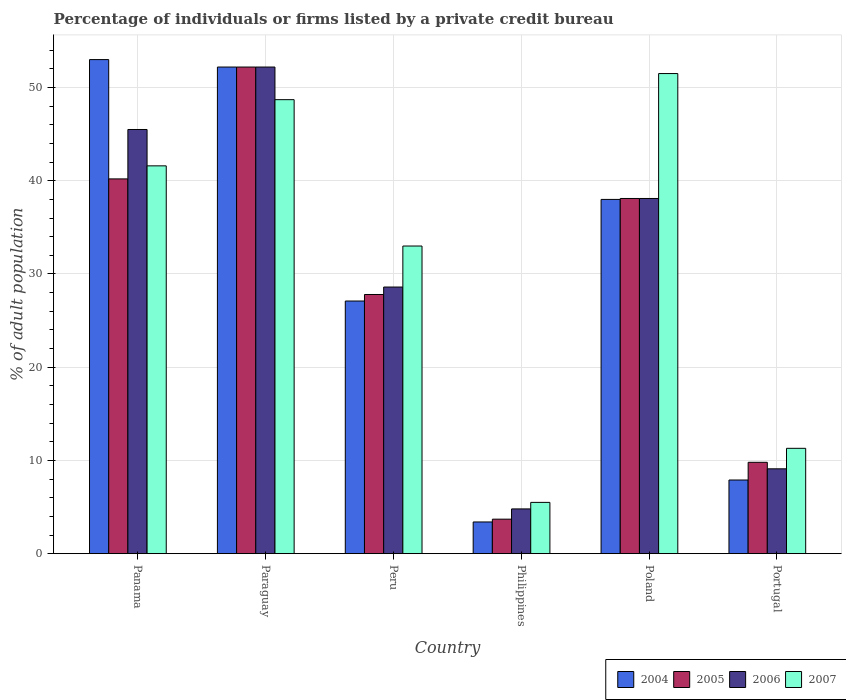How many different coloured bars are there?
Give a very brief answer. 4. Are the number of bars per tick equal to the number of legend labels?
Offer a terse response. Yes. Are the number of bars on each tick of the X-axis equal?
Your answer should be compact. Yes. What is the label of the 3rd group of bars from the left?
Your answer should be very brief. Peru. In how many cases, is the number of bars for a given country not equal to the number of legend labels?
Provide a succinct answer. 0. What is the percentage of population listed by a private credit bureau in 2007 in Paraguay?
Your answer should be very brief. 48.7. Across all countries, what is the maximum percentage of population listed by a private credit bureau in 2004?
Your response must be concise. 53. Across all countries, what is the minimum percentage of population listed by a private credit bureau in 2007?
Provide a succinct answer. 5.5. In which country was the percentage of population listed by a private credit bureau in 2005 maximum?
Give a very brief answer. Paraguay. What is the total percentage of population listed by a private credit bureau in 2004 in the graph?
Provide a short and direct response. 181.6. What is the difference between the percentage of population listed by a private credit bureau in 2004 in Panama and that in Philippines?
Keep it short and to the point. 49.6. What is the difference between the percentage of population listed by a private credit bureau in 2004 in Paraguay and the percentage of population listed by a private credit bureau in 2007 in Peru?
Make the answer very short. 19.2. What is the average percentage of population listed by a private credit bureau in 2004 per country?
Provide a short and direct response. 30.27. What is the difference between the percentage of population listed by a private credit bureau of/in 2006 and percentage of population listed by a private credit bureau of/in 2007 in Peru?
Ensure brevity in your answer.  -4.4. In how many countries, is the percentage of population listed by a private credit bureau in 2007 greater than 40 %?
Your answer should be very brief. 3. What is the ratio of the percentage of population listed by a private credit bureau in 2007 in Philippines to that in Portugal?
Ensure brevity in your answer.  0.49. Is the difference between the percentage of population listed by a private credit bureau in 2006 in Paraguay and Philippines greater than the difference between the percentage of population listed by a private credit bureau in 2007 in Paraguay and Philippines?
Ensure brevity in your answer.  Yes. What is the difference between the highest and the second highest percentage of population listed by a private credit bureau in 2006?
Give a very brief answer. 6.7. What is the difference between the highest and the lowest percentage of population listed by a private credit bureau in 2005?
Offer a terse response. 48.5. What does the 2nd bar from the left in Paraguay represents?
Provide a short and direct response. 2005. Is it the case that in every country, the sum of the percentage of population listed by a private credit bureau in 2005 and percentage of population listed by a private credit bureau in 2007 is greater than the percentage of population listed by a private credit bureau in 2006?
Your response must be concise. Yes. How many bars are there?
Keep it short and to the point. 24. Are all the bars in the graph horizontal?
Provide a succinct answer. No. Are the values on the major ticks of Y-axis written in scientific E-notation?
Your response must be concise. No. Does the graph contain any zero values?
Provide a succinct answer. No. Where does the legend appear in the graph?
Your response must be concise. Bottom right. How many legend labels are there?
Ensure brevity in your answer.  4. What is the title of the graph?
Your response must be concise. Percentage of individuals or firms listed by a private credit bureau. Does "1986" appear as one of the legend labels in the graph?
Make the answer very short. No. What is the label or title of the Y-axis?
Ensure brevity in your answer.  % of adult population. What is the % of adult population of 2005 in Panama?
Make the answer very short. 40.2. What is the % of adult population in 2006 in Panama?
Provide a succinct answer. 45.5. What is the % of adult population in 2007 in Panama?
Ensure brevity in your answer.  41.6. What is the % of adult population in 2004 in Paraguay?
Provide a short and direct response. 52.2. What is the % of adult population in 2005 in Paraguay?
Your answer should be very brief. 52.2. What is the % of adult population in 2006 in Paraguay?
Offer a very short reply. 52.2. What is the % of adult population in 2007 in Paraguay?
Provide a short and direct response. 48.7. What is the % of adult population of 2004 in Peru?
Offer a terse response. 27.1. What is the % of adult population in 2005 in Peru?
Give a very brief answer. 27.8. What is the % of adult population in 2006 in Peru?
Your answer should be very brief. 28.6. What is the % of adult population in 2004 in Philippines?
Offer a terse response. 3.4. What is the % of adult population in 2005 in Philippines?
Ensure brevity in your answer.  3.7. What is the % of adult population of 2006 in Philippines?
Provide a short and direct response. 4.8. What is the % of adult population in 2005 in Poland?
Give a very brief answer. 38.1. What is the % of adult population of 2006 in Poland?
Your response must be concise. 38.1. What is the % of adult population of 2007 in Poland?
Ensure brevity in your answer.  51.5. What is the % of adult population of 2004 in Portugal?
Make the answer very short. 7.9. What is the % of adult population of 2005 in Portugal?
Make the answer very short. 9.8. What is the % of adult population in 2007 in Portugal?
Your answer should be very brief. 11.3. Across all countries, what is the maximum % of adult population in 2005?
Provide a succinct answer. 52.2. Across all countries, what is the maximum % of adult population of 2006?
Provide a short and direct response. 52.2. Across all countries, what is the maximum % of adult population in 2007?
Your answer should be compact. 51.5. Across all countries, what is the minimum % of adult population in 2005?
Offer a very short reply. 3.7. Across all countries, what is the minimum % of adult population in 2006?
Provide a short and direct response. 4.8. What is the total % of adult population of 2004 in the graph?
Your answer should be very brief. 181.6. What is the total % of adult population in 2005 in the graph?
Offer a terse response. 171.8. What is the total % of adult population of 2006 in the graph?
Your answer should be very brief. 178.3. What is the total % of adult population of 2007 in the graph?
Your answer should be compact. 191.6. What is the difference between the % of adult population in 2004 in Panama and that in Paraguay?
Offer a terse response. 0.8. What is the difference between the % of adult population in 2004 in Panama and that in Peru?
Your answer should be very brief. 25.9. What is the difference between the % of adult population in 2006 in Panama and that in Peru?
Provide a succinct answer. 16.9. What is the difference between the % of adult population in 2007 in Panama and that in Peru?
Your answer should be very brief. 8.6. What is the difference between the % of adult population of 2004 in Panama and that in Philippines?
Offer a very short reply. 49.6. What is the difference between the % of adult population in 2005 in Panama and that in Philippines?
Give a very brief answer. 36.5. What is the difference between the % of adult population in 2006 in Panama and that in Philippines?
Offer a terse response. 40.7. What is the difference between the % of adult population of 2007 in Panama and that in Philippines?
Make the answer very short. 36.1. What is the difference between the % of adult population of 2004 in Panama and that in Poland?
Provide a short and direct response. 15. What is the difference between the % of adult population in 2005 in Panama and that in Poland?
Your answer should be compact. 2.1. What is the difference between the % of adult population of 2006 in Panama and that in Poland?
Give a very brief answer. 7.4. What is the difference between the % of adult population of 2004 in Panama and that in Portugal?
Keep it short and to the point. 45.1. What is the difference between the % of adult population in 2005 in Panama and that in Portugal?
Keep it short and to the point. 30.4. What is the difference between the % of adult population in 2006 in Panama and that in Portugal?
Your response must be concise. 36.4. What is the difference between the % of adult population in 2007 in Panama and that in Portugal?
Ensure brevity in your answer.  30.3. What is the difference between the % of adult population of 2004 in Paraguay and that in Peru?
Make the answer very short. 25.1. What is the difference between the % of adult population of 2005 in Paraguay and that in Peru?
Offer a terse response. 24.4. What is the difference between the % of adult population in 2006 in Paraguay and that in Peru?
Offer a terse response. 23.6. What is the difference between the % of adult population of 2007 in Paraguay and that in Peru?
Provide a succinct answer. 15.7. What is the difference between the % of adult population of 2004 in Paraguay and that in Philippines?
Provide a short and direct response. 48.8. What is the difference between the % of adult population of 2005 in Paraguay and that in Philippines?
Your response must be concise. 48.5. What is the difference between the % of adult population of 2006 in Paraguay and that in Philippines?
Keep it short and to the point. 47.4. What is the difference between the % of adult population of 2007 in Paraguay and that in Philippines?
Offer a very short reply. 43.2. What is the difference between the % of adult population in 2004 in Paraguay and that in Poland?
Make the answer very short. 14.2. What is the difference between the % of adult population in 2005 in Paraguay and that in Poland?
Your response must be concise. 14.1. What is the difference between the % of adult population in 2007 in Paraguay and that in Poland?
Provide a short and direct response. -2.8. What is the difference between the % of adult population of 2004 in Paraguay and that in Portugal?
Your answer should be very brief. 44.3. What is the difference between the % of adult population in 2005 in Paraguay and that in Portugal?
Ensure brevity in your answer.  42.4. What is the difference between the % of adult population in 2006 in Paraguay and that in Portugal?
Offer a terse response. 43.1. What is the difference between the % of adult population in 2007 in Paraguay and that in Portugal?
Ensure brevity in your answer.  37.4. What is the difference between the % of adult population in 2004 in Peru and that in Philippines?
Ensure brevity in your answer.  23.7. What is the difference between the % of adult population of 2005 in Peru and that in Philippines?
Provide a succinct answer. 24.1. What is the difference between the % of adult population of 2006 in Peru and that in Philippines?
Make the answer very short. 23.8. What is the difference between the % of adult population of 2004 in Peru and that in Poland?
Keep it short and to the point. -10.9. What is the difference between the % of adult population in 2005 in Peru and that in Poland?
Your answer should be compact. -10.3. What is the difference between the % of adult population in 2007 in Peru and that in Poland?
Ensure brevity in your answer.  -18.5. What is the difference between the % of adult population of 2004 in Peru and that in Portugal?
Your answer should be very brief. 19.2. What is the difference between the % of adult population of 2007 in Peru and that in Portugal?
Your answer should be very brief. 21.7. What is the difference between the % of adult population in 2004 in Philippines and that in Poland?
Provide a short and direct response. -34.6. What is the difference between the % of adult population of 2005 in Philippines and that in Poland?
Your answer should be very brief. -34.4. What is the difference between the % of adult population of 2006 in Philippines and that in Poland?
Offer a terse response. -33.3. What is the difference between the % of adult population in 2007 in Philippines and that in Poland?
Ensure brevity in your answer.  -46. What is the difference between the % of adult population of 2004 in Philippines and that in Portugal?
Keep it short and to the point. -4.5. What is the difference between the % of adult population of 2006 in Philippines and that in Portugal?
Offer a very short reply. -4.3. What is the difference between the % of adult population in 2004 in Poland and that in Portugal?
Provide a short and direct response. 30.1. What is the difference between the % of adult population in 2005 in Poland and that in Portugal?
Give a very brief answer. 28.3. What is the difference between the % of adult population of 2007 in Poland and that in Portugal?
Offer a terse response. 40.2. What is the difference between the % of adult population of 2004 in Panama and the % of adult population of 2005 in Paraguay?
Ensure brevity in your answer.  0.8. What is the difference between the % of adult population in 2004 in Panama and the % of adult population in 2006 in Paraguay?
Offer a very short reply. 0.8. What is the difference between the % of adult population in 2005 in Panama and the % of adult population in 2007 in Paraguay?
Provide a succinct answer. -8.5. What is the difference between the % of adult population of 2006 in Panama and the % of adult population of 2007 in Paraguay?
Your answer should be very brief. -3.2. What is the difference between the % of adult population in 2004 in Panama and the % of adult population in 2005 in Peru?
Your response must be concise. 25.2. What is the difference between the % of adult population of 2004 in Panama and the % of adult population of 2006 in Peru?
Give a very brief answer. 24.4. What is the difference between the % of adult population in 2004 in Panama and the % of adult population in 2007 in Peru?
Your answer should be very brief. 20. What is the difference between the % of adult population of 2004 in Panama and the % of adult population of 2005 in Philippines?
Make the answer very short. 49.3. What is the difference between the % of adult population of 2004 in Panama and the % of adult population of 2006 in Philippines?
Provide a succinct answer. 48.2. What is the difference between the % of adult population of 2004 in Panama and the % of adult population of 2007 in Philippines?
Offer a terse response. 47.5. What is the difference between the % of adult population in 2005 in Panama and the % of adult population in 2006 in Philippines?
Keep it short and to the point. 35.4. What is the difference between the % of adult population of 2005 in Panama and the % of adult population of 2007 in Philippines?
Keep it short and to the point. 34.7. What is the difference between the % of adult population in 2004 in Panama and the % of adult population in 2005 in Poland?
Ensure brevity in your answer.  14.9. What is the difference between the % of adult population in 2004 in Panama and the % of adult population in 2006 in Poland?
Your response must be concise. 14.9. What is the difference between the % of adult population of 2005 in Panama and the % of adult population of 2006 in Poland?
Offer a terse response. 2.1. What is the difference between the % of adult population in 2005 in Panama and the % of adult population in 2007 in Poland?
Offer a very short reply. -11.3. What is the difference between the % of adult population of 2006 in Panama and the % of adult population of 2007 in Poland?
Your answer should be very brief. -6. What is the difference between the % of adult population in 2004 in Panama and the % of adult population in 2005 in Portugal?
Provide a short and direct response. 43.2. What is the difference between the % of adult population in 2004 in Panama and the % of adult population in 2006 in Portugal?
Give a very brief answer. 43.9. What is the difference between the % of adult population of 2004 in Panama and the % of adult population of 2007 in Portugal?
Offer a very short reply. 41.7. What is the difference between the % of adult population in 2005 in Panama and the % of adult population in 2006 in Portugal?
Your answer should be compact. 31.1. What is the difference between the % of adult population in 2005 in Panama and the % of adult population in 2007 in Portugal?
Ensure brevity in your answer.  28.9. What is the difference between the % of adult population in 2006 in Panama and the % of adult population in 2007 in Portugal?
Ensure brevity in your answer.  34.2. What is the difference between the % of adult population of 2004 in Paraguay and the % of adult population of 2005 in Peru?
Your answer should be very brief. 24.4. What is the difference between the % of adult population in 2004 in Paraguay and the % of adult population in 2006 in Peru?
Keep it short and to the point. 23.6. What is the difference between the % of adult population of 2005 in Paraguay and the % of adult population of 2006 in Peru?
Offer a very short reply. 23.6. What is the difference between the % of adult population of 2004 in Paraguay and the % of adult population of 2005 in Philippines?
Your response must be concise. 48.5. What is the difference between the % of adult population in 2004 in Paraguay and the % of adult population in 2006 in Philippines?
Offer a very short reply. 47.4. What is the difference between the % of adult population of 2004 in Paraguay and the % of adult population of 2007 in Philippines?
Ensure brevity in your answer.  46.7. What is the difference between the % of adult population of 2005 in Paraguay and the % of adult population of 2006 in Philippines?
Your answer should be compact. 47.4. What is the difference between the % of adult population of 2005 in Paraguay and the % of adult population of 2007 in Philippines?
Your answer should be very brief. 46.7. What is the difference between the % of adult population in 2006 in Paraguay and the % of adult population in 2007 in Philippines?
Ensure brevity in your answer.  46.7. What is the difference between the % of adult population of 2004 in Paraguay and the % of adult population of 2005 in Poland?
Provide a short and direct response. 14.1. What is the difference between the % of adult population in 2004 in Paraguay and the % of adult population in 2006 in Poland?
Offer a very short reply. 14.1. What is the difference between the % of adult population in 2005 in Paraguay and the % of adult population in 2007 in Poland?
Your response must be concise. 0.7. What is the difference between the % of adult population of 2006 in Paraguay and the % of adult population of 2007 in Poland?
Ensure brevity in your answer.  0.7. What is the difference between the % of adult population in 2004 in Paraguay and the % of adult population in 2005 in Portugal?
Ensure brevity in your answer.  42.4. What is the difference between the % of adult population of 2004 in Paraguay and the % of adult population of 2006 in Portugal?
Keep it short and to the point. 43.1. What is the difference between the % of adult population of 2004 in Paraguay and the % of adult population of 2007 in Portugal?
Give a very brief answer. 40.9. What is the difference between the % of adult population of 2005 in Paraguay and the % of adult population of 2006 in Portugal?
Provide a short and direct response. 43.1. What is the difference between the % of adult population in 2005 in Paraguay and the % of adult population in 2007 in Portugal?
Provide a succinct answer. 40.9. What is the difference between the % of adult population of 2006 in Paraguay and the % of adult population of 2007 in Portugal?
Your response must be concise. 40.9. What is the difference between the % of adult population of 2004 in Peru and the % of adult population of 2005 in Philippines?
Keep it short and to the point. 23.4. What is the difference between the % of adult population of 2004 in Peru and the % of adult population of 2006 in Philippines?
Provide a succinct answer. 22.3. What is the difference between the % of adult population in 2004 in Peru and the % of adult population in 2007 in Philippines?
Give a very brief answer. 21.6. What is the difference between the % of adult population of 2005 in Peru and the % of adult population of 2007 in Philippines?
Ensure brevity in your answer.  22.3. What is the difference between the % of adult population of 2006 in Peru and the % of adult population of 2007 in Philippines?
Your answer should be very brief. 23.1. What is the difference between the % of adult population of 2004 in Peru and the % of adult population of 2007 in Poland?
Give a very brief answer. -24.4. What is the difference between the % of adult population of 2005 in Peru and the % of adult population of 2006 in Poland?
Give a very brief answer. -10.3. What is the difference between the % of adult population of 2005 in Peru and the % of adult population of 2007 in Poland?
Ensure brevity in your answer.  -23.7. What is the difference between the % of adult population of 2006 in Peru and the % of adult population of 2007 in Poland?
Your answer should be compact. -22.9. What is the difference between the % of adult population in 2004 in Peru and the % of adult population in 2007 in Portugal?
Offer a very short reply. 15.8. What is the difference between the % of adult population in 2005 in Peru and the % of adult population in 2006 in Portugal?
Your answer should be very brief. 18.7. What is the difference between the % of adult population of 2006 in Peru and the % of adult population of 2007 in Portugal?
Your answer should be compact. 17.3. What is the difference between the % of adult population in 2004 in Philippines and the % of adult population in 2005 in Poland?
Your response must be concise. -34.7. What is the difference between the % of adult population of 2004 in Philippines and the % of adult population of 2006 in Poland?
Ensure brevity in your answer.  -34.7. What is the difference between the % of adult population in 2004 in Philippines and the % of adult population in 2007 in Poland?
Give a very brief answer. -48.1. What is the difference between the % of adult population in 2005 in Philippines and the % of adult population in 2006 in Poland?
Ensure brevity in your answer.  -34.4. What is the difference between the % of adult population in 2005 in Philippines and the % of adult population in 2007 in Poland?
Ensure brevity in your answer.  -47.8. What is the difference between the % of adult population of 2006 in Philippines and the % of adult population of 2007 in Poland?
Provide a short and direct response. -46.7. What is the difference between the % of adult population in 2004 in Philippines and the % of adult population in 2005 in Portugal?
Offer a terse response. -6.4. What is the difference between the % of adult population in 2004 in Philippines and the % of adult population in 2006 in Portugal?
Offer a very short reply. -5.7. What is the difference between the % of adult population of 2005 in Philippines and the % of adult population of 2007 in Portugal?
Make the answer very short. -7.6. What is the difference between the % of adult population of 2004 in Poland and the % of adult population of 2005 in Portugal?
Your answer should be very brief. 28.2. What is the difference between the % of adult population in 2004 in Poland and the % of adult population in 2006 in Portugal?
Ensure brevity in your answer.  28.9. What is the difference between the % of adult population of 2004 in Poland and the % of adult population of 2007 in Portugal?
Ensure brevity in your answer.  26.7. What is the difference between the % of adult population in 2005 in Poland and the % of adult population in 2006 in Portugal?
Make the answer very short. 29. What is the difference between the % of adult population of 2005 in Poland and the % of adult population of 2007 in Portugal?
Provide a short and direct response. 26.8. What is the difference between the % of adult population of 2006 in Poland and the % of adult population of 2007 in Portugal?
Give a very brief answer. 26.8. What is the average % of adult population of 2004 per country?
Make the answer very short. 30.27. What is the average % of adult population of 2005 per country?
Keep it short and to the point. 28.63. What is the average % of adult population of 2006 per country?
Give a very brief answer. 29.72. What is the average % of adult population of 2007 per country?
Offer a terse response. 31.93. What is the difference between the % of adult population in 2004 and % of adult population in 2005 in Panama?
Make the answer very short. 12.8. What is the difference between the % of adult population of 2006 and % of adult population of 2007 in Panama?
Your answer should be very brief. 3.9. What is the difference between the % of adult population of 2004 and % of adult population of 2005 in Paraguay?
Your response must be concise. 0. What is the difference between the % of adult population of 2004 and % of adult population of 2007 in Paraguay?
Offer a terse response. 3.5. What is the difference between the % of adult population in 2006 and % of adult population in 2007 in Paraguay?
Your answer should be compact. 3.5. What is the difference between the % of adult population in 2004 and % of adult population in 2006 in Peru?
Your answer should be compact. -1.5. What is the difference between the % of adult population of 2004 and % of adult population of 2007 in Peru?
Your answer should be very brief. -5.9. What is the difference between the % of adult population in 2005 and % of adult population in 2007 in Peru?
Keep it short and to the point. -5.2. What is the difference between the % of adult population of 2006 and % of adult population of 2007 in Peru?
Provide a short and direct response. -4.4. What is the difference between the % of adult population of 2004 and % of adult population of 2005 in Philippines?
Your answer should be very brief. -0.3. What is the difference between the % of adult population in 2004 and % of adult population in 2006 in Philippines?
Offer a very short reply. -1.4. What is the difference between the % of adult population of 2004 and % of adult population of 2007 in Philippines?
Your answer should be compact. -2.1. What is the difference between the % of adult population in 2005 and % of adult population in 2006 in Philippines?
Offer a terse response. -1.1. What is the difference between the % of adult population in 2004 and % of adult population in 2005 in Poland?
Offer a very short reply. -0.1. What is the difference between the % of adult population in 2004 and % of adult population in 2006 in Poland?
Your answer should be very brief. -0.1. What is the difference between the % of adult population of 2004 and % of adult population of 2007 in Poland?
Make the answer very short. -13.5. What is the difference between the % of adult population of 2005 and % of adult population of 2006 in Poland?
Offer a very short reply. 0. What is the difference between the % of adult population of 2005 and % of adult population of 2007 in Poland?
Ensure brevity in your answer.  -13.4. What is the difference between the % of adult population of 2005 and % of adult population of 2007 in Portugal?
Keep it short and to the point. -1.5. What is the difference between the % of adult population of 2006 and % of adult population of 2007 in Portugal?
Offer a very short reply. -2.2. What is the ratio of the % of adult population in 2004 in Panama to that in Paraguay?
Your answer should be very brief. 1.02. What is the ratio of the % of adult population in 2005 in Panama to that in Paraguay?
Offer a very short reply. 0.77. What is the ratio of the % of adult population of 2006 in Panama to that in Paraguay?
Provide a succinct answer. 0.87. What is the ratio of the % of adult population in 2007 in Panama to that in Paraguay?
Your answer should be very brief. 0.85. What is the ratio of the % of adult population of 2004 in Panama to that in Peru?
Give a very brief answer. 1.96. What is the ratio of the % of adult population in 2005 in Panama to that in Peru?
Offer a very short reply. 1.45. What is the ratio of the % of adult population of 2006 in Panama to that in Peru?
Make the answer very short. 1.59. What is the ratio of the % of adult population of 2007 in Panama to that in Peru?
Provide a short and direct response. 1.26. What is the ratio of the % of adult population in 2004 in Panama to that in Philippines?
Your answer should be very brief. 15.59. What is the ratio of the % of adult population of 2005 in Panama to that in Philippines?
Offer a terse response. 10.86. What is the ratio of the % of adult population in 2006 in Panama to that in Philippines?
Ensure brevity in your answer.  9.48. What is the ratio of the % of adult population in 2007 in Panama to that in Philippines?
Offer a very short reply. 7.56. What is the ratio of the % of adult population in 2004 in Panama to that in Poland?
Your answer should be very brief. 1.39. What is the ratio of the % of adult population of 2005 in Panama to that in Poland?
Make the answer very short. 1.06. What is the ratio of the % of adult population in 2006 in Panama to that in Poland?
Give a very brief answer. 1.19. What is the ratio of the % of adult population in 2007 in Panama to that in Poland?
Give a very brief answer. 0.81. What is the ratio of the % of adult population in 2004 in Panama to that in Portugal?
Ensure brevity in your answer.  6.71. What is the ratio of the % of adult population of 2005 in Panama to that in Portugal?
Provide a succinct answer. 4.1. What is the ratio of the % of adult population in 2006 in Panama to that in Portugal?
Give a very brief answer. 5. What is the ratio of the % of adult population in 2007 in Panama to that in Portugal?
Keep it short and to the point. 3.68. What is the ratio of the % of adult population in 2004 in Paraguay to that in Peru?
Give a very brief answer. 1.93. What is the ratio of the % of adult population of 2005 in Paraguay to that in Peru?
Ensure brevity in your answer.  1.88. What is the ratio of the % of adult population of 2006 in Paraguay to that in Peru?
Provide a short and direct response. 1.83. What is the ratio of the % of adult population in 2007 in Paraguay to that in Peru?
Offer a terse response. 1.48. What is the ratio of the % of adult population in 2004 in Paraguay to that in Philippines?
Make the answer very short. 15.35. What is the ratio of the % of adult population in 2005 in Paraguay to that in Philippines?
Your answer should be very brief. 14.11. What is the ratio of the % of adult population in 2006 in Paraguay to that in Philippines?
Make the answer very short. 10.88. What is the ratio of the % of adult population of 2007 in Paraguay to that in Philippines?
Your answer should be compact. 8.85. What is the ratio of the % of adult population of 2004 in Paraguay to that in Poland?
Your answer should be compact. 1.37. What is the ratio of the % of adult population of 2005 in Paraguay to that in Poland?
Your response must be concise. 1.37. What is the ratio of the % of adult population of 2006 in Paraguay to that in Poland?
Your answer should be compact. 1.37. What is the ratio of the % of adult population of 2007 in Paraguay to that in Poland?
Make the answer very short. 0.95. What is the ratio of the % of adult population of 2004 in Paraguay to that in Portugal?
Your answer should be compact. 6.61. What is the ratio of the % of adult population of 2005 in Paraguay to that in Portugal?
Provide a short and direct response. 5.33. What is the ratio of the % of adult population of 2006 in Paraguay to that in Portugal?
Ensure brevity in your answer.  5.74. What is the ratio of the % of adult population of 2007 in Paraguay to that in Portugal?
Your answer should be compact. 4.31. What is the ratio of the % of adult population in 2004 in Peru to that in Philippines?
Give a very brief answer. 7.97. What is the ratio of the % of adult population of 2005 in Peru to that in Philippines?
Make the answer very short. 7.51. What is the ratio of the % of adult population in 2006 in Peru to that in Philippines?
Provide a short and direct response. 5.96. What is the ratio of the % of adult population of 2004 in Peru to that in Poland?
Make the answer very short. 0.71. What is the ratio of the % of adult population in 2005 in Peru to that in Poland?
Offer a very short reply. 0.73. What is the ratio of the % of adult population of 2006 in Peru to that in Poland?
Ensure brevity in your answer.  0.75. What is the ratio of the % of adult population in 2007 in Peru to that in Poland?
Make the answer very short. 0.64. What is the ratio of the % of adult population of 2004 in Peru to that in Portugal?
Give a very brief answer. 3.43. What is the ratio of the % of adult population of 2005 in Peru to that in Portugal?
Provide a short and direct response. 2.84. What is the ratio of the % of adult population of 2006 in Peru to that in Portugal?
Your answer should be compact. 3.14. What is the ratio of the % of adult population of 2007 in Peru to that in Portugal?
Offer a terse response. 2.92. What is the ratio of the % of adult population of 2004 in Philippines to that in Poland?
Your response must be concise. 0.09. What is the ratio of the % of adult population of 2005 in Philippines to that in Poland?
Give a very brief answer. 0.1. What is the ratio of the % of adult population of 2006 in Philippines to that in Poland?
Give a very brief answer. 0.13. What is the ratio of the % of adult population of 2007 in Philippines to that in Poland?
Your answer should be compact. 0.11. What is the ratio of the % of adult population in 2004 in Philippines to that in Portugal?
Provide a succinct answer. 0.43. What is the ratio of the % of adult population in 2005 in Philippines to that in Portugal?
Offer a very short reply. 0.38. What is the ratio of the % of adult population of 2006 in Philippines to that in Portugal?
Your answer should be compact. 0.53. What is the ratio of the % of adult population in 2007 in Philippines to that in Portugal?
Your response must be concise. 0.49. What is the ratio of the % of adult population in 2004 in Poland to that in Portugal?
Your answer should be very brief. 4.81. What is the ratio of the % of adult population of 2005 in Poland to that in Portugal?
Make the answer very short. 3.89. What is the ratio of the % of adult population of 2006 in Poland to that in Portugal?
Your answer should be very brief. 4.19. What is the ratio of the % of adult population of 2007 in Poland to that in Portugal?
Provide a succinct answer. 4.56. What is the difference between the highest and the second highest % of adult population of 2006?
Offer a very short reply. 6.7. What is the difference between the highest and the lowest % of adult population of 2004?
Your response must be concise. 49.6. What is the difference between the highest and the lowest % of adult population of 2005?
Offer a very short reply. 48.5. What is the difference between the highest and the lowest % of adult population of 2006?
Your answer should be compact. 47.4. 